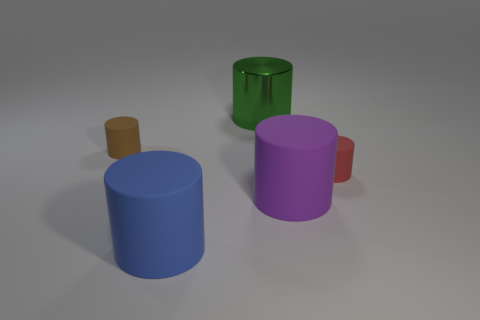Subtract all gray cylinders. Subtract all red balls. How many cylinders are left? 5 Add 4 tiny brown cylinders. How many objects exist? 9 Subtract 1 red cylinders. How many objects are left? 4 Subtract all green things. Subtract all large balls. How many objects are left? 4 Add 4 blue rubber objects. How many blue rubber objects are left? 5 Add 3 large cylinders. How many large cylinders exist? 6 